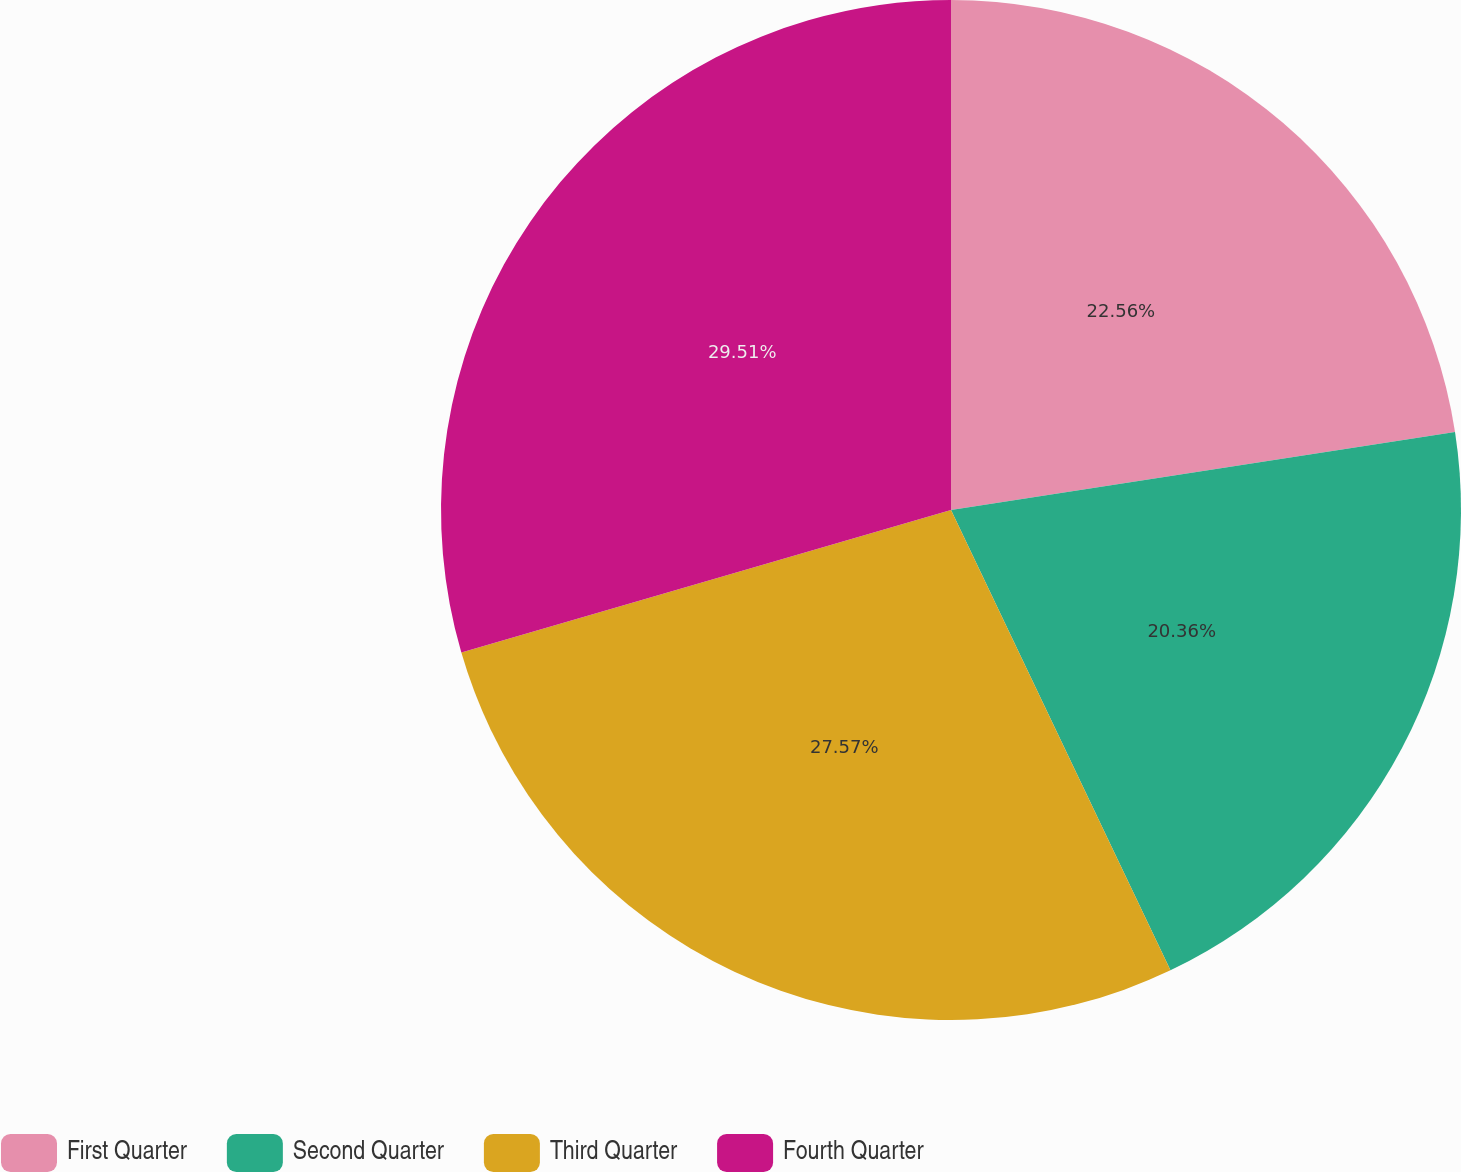Convert chart to OTSL. <chart><loc_0><loc_0><loc_500><loc_500><pie_chart><fcel>First Quarter<fcel>Second Quarter<fcel>Third Quarter<fcel>Fourth Quarter<nl><fcel>22.56%<fcel>20.36%<fcel>27.57%<fcel>29.51%<nl></chart> 